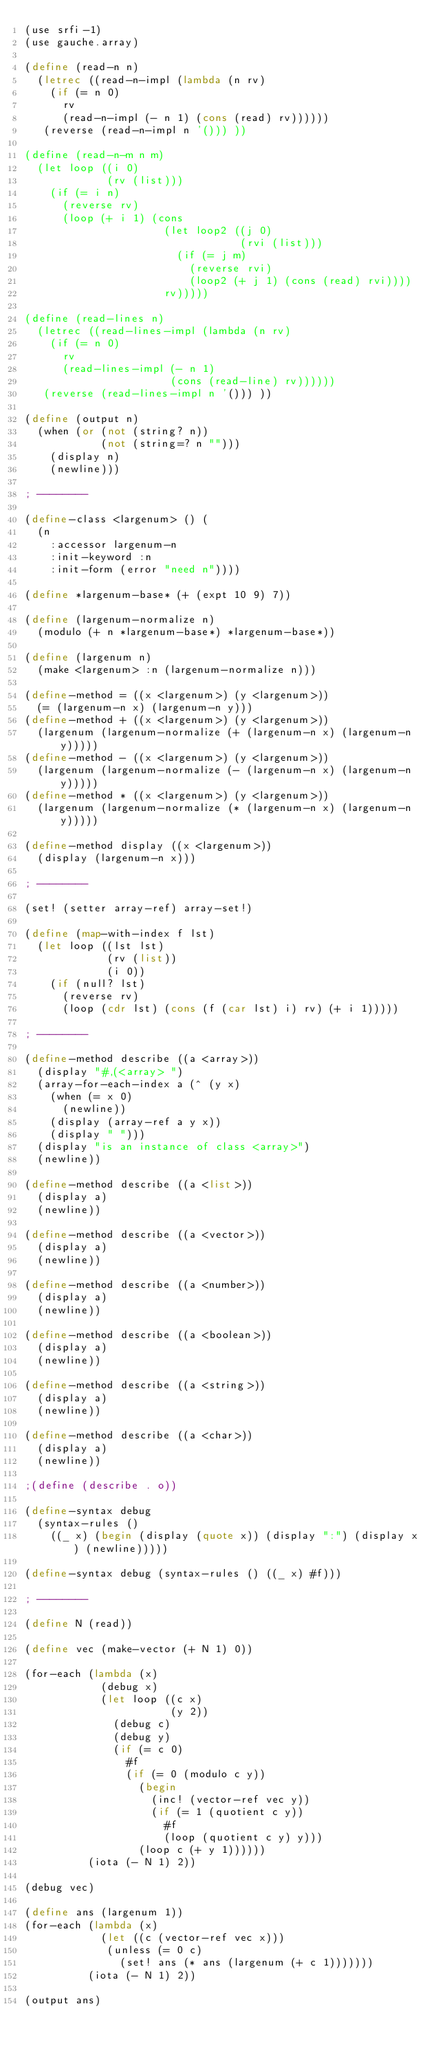Convert code to text. <code><loc_0><loc_0><loc_500><loc_500><_Scheme_>(use srfi-1)
(use gauche.array)

(define (read-n n)
  (letrec ((read-n-impl (lambda (n rv)
    (if (= n 0)
      rv
      (read-n-impl (- n 1) (cons (read) rv))))))
   (reverse (read-n-impl n '())) ))

(define (read-n-m n m)
  (let loop ((i 0)
             (rv (list)))
    (if (= i n)
      (reverse rv)
      (loop (+ i 1) (cons 
                      (let loop2 ((j 0)
                                  (rvi (list)))
                        (if (= j m)
                          (reverse rvi)
                          (loop2 (+ j 1) (cons (read) rvi))))
                      rv)))))

(define (read-lines n)
  (letrec ((read-lines-impl (lambda (n rv)
    (if (= n 0)
      rv
      (read-lines-impl (- n 1)
                       (cons (read-line) rv))))))
   (reverse (read-lines-impl n '())) ))

(define (output n)
  (when (or (not (string? n))
            (not (string=? n "")))
    (display n) 
    (newline)))

; --------

(define-class <largenum> () (
  (n
    :accessor largenum-n
    :init-keyword :n
    :init-form (error "need n"))))

(define *largenum-base* (+ (expt 10 9) 7))

(define (largenum-normalize n)
  (modulo (+ n *largenum-base*) *largenum-base*))

(define (largenum n)
  (make <largenum> :n (largenum-normalize n)))

(define-method = ((x <largenum>) (y <largenum>))
  (= (largenum-n x) (largenum-n y)))
(define-method + ((x <largenum>) (y <largenum>))
  (largenum (largenum-normalize (+ (largenum-n x) (largenum-n y)))))
(define-method - ((x <largenum>) (y <largenum>))
  (largenum (largenum-normalize (- (largenum-n x) (largenum-n y)))))
(define-method * ((x <largenum>) (y <largenum>))
  (largenum (largenum-normalize (* (largenum-n x) (largenum-n y)))))

(define-method display ((x <largenum>))
  (display (largenum-n x)))

; --------

(set! (setter array-ref) array-set!)

(define (map-with-index f lst)
  (let loop ((lst lst)
             (rv (list))
             (i 0))
    (if (null? lst)
      (reverse rv)
      (loop (cdr lst) (cons (f (car lst) i) rv) (+ i 1)))))

; --------

(define-method describe ((a <array>))
  (display "#,(<array> ")
  (array-for-each-index a (^ (y x)
    (when (= x 0)
      (newline))
    (display (array-ref a y x))
    (display " ")))
  (display "is an instance of class <array>")
  (newline))

(define-method describe ((a <list>))
  (display a)
  (newline))

(define-method describe ((a <vector>))
  (display a)
  (newline))

(define-method describe ((a <number>))
  (display a)
  (newline))

(define-method describe ((a <boolean>))
  (display a)
  (newline))

(define-method describe ((a <string>))
  (display a)
  (newline))

(define-method describe ((a <char>))
  (display a)
  (newline))

;(define (describe . o))

(define-syntax debug
  (syntax-rules ()
    ((_ x) (begin (display (quote x)) (display ":") (display x) (newline)))))

(define-syntax debug (syntax-rules () ((_ x) #f))) 

; --------

(define N (read))

(define vec (make-vector (+ N 1) 0))

(for-each (lambda (x)
            (debug x)
            (let loop ((c x)
                       (y 2))
              (debug c)
              (debug y)
              (if (= c 0)
                #f
                (if (= 0 (modulo c y))
                  (begin
                    (inc! (vector-ref vec y))
                    (if (= 1 (quotient c y))
                      #f
                      (loop (quotient c y) y)))
                  (loop c (+ y 1))))))
          (iota (- N 1) 2))

(debug vec)

(define ans (largenum 1))
(for-each (lambda (x)
            (let ((c (vector-ref vec x)))
             (unless (= 0 c)
               (set! ans (* ans (largenum (+ c 1)))))))
          (iota (- N 1) 2))

(output ans)
</code> 